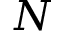<formula> <loc_0><loc_0><loc_500><loc_500>N</formula> 